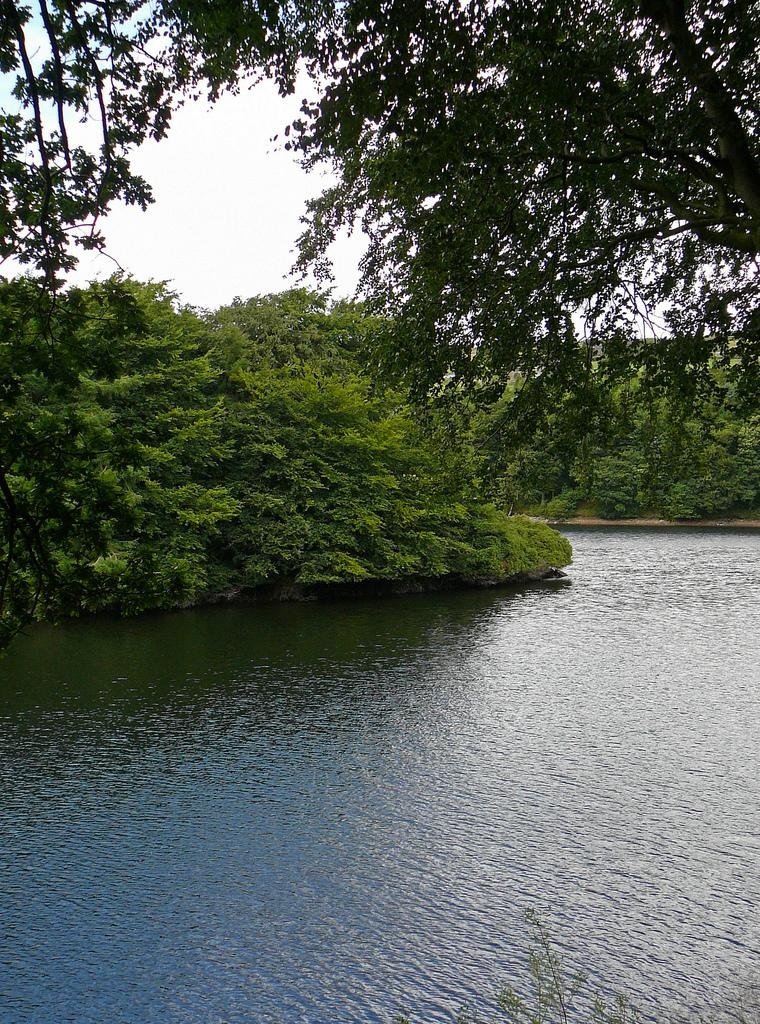What is visible in the image? There is water visible in the image. What can be seen in the background of the image? There are trees in the background of the image. What type of lawyer is standing near the water in the image? There is no lawyer present in the image; it only features water and trees in the background. 